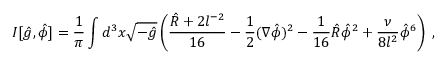Convert formula to latex. <formula><loc_0><loc_0><loc_500><loc_500>I [ \hat { g } , \hat { \phi } ] = \frac { 1 } { \pi } \int d ^ { 3 } x \sqrt { - \hat { g } } \left ( \frac { \hat { R } + 2 l ^ { - 2 } } { 1 6 } - \frac { 1 } { 2 } ( \nabla \hat { \phi } ) ^ { 2 } - \frac { 1 } { 1 6 } \hat { R } \hat { \phi } ^ { 2 } + \frac { \nu } { 8 l ^ { 2 } } \hat { \phi } ^ { 6 } \right ) \, ,</formula> 